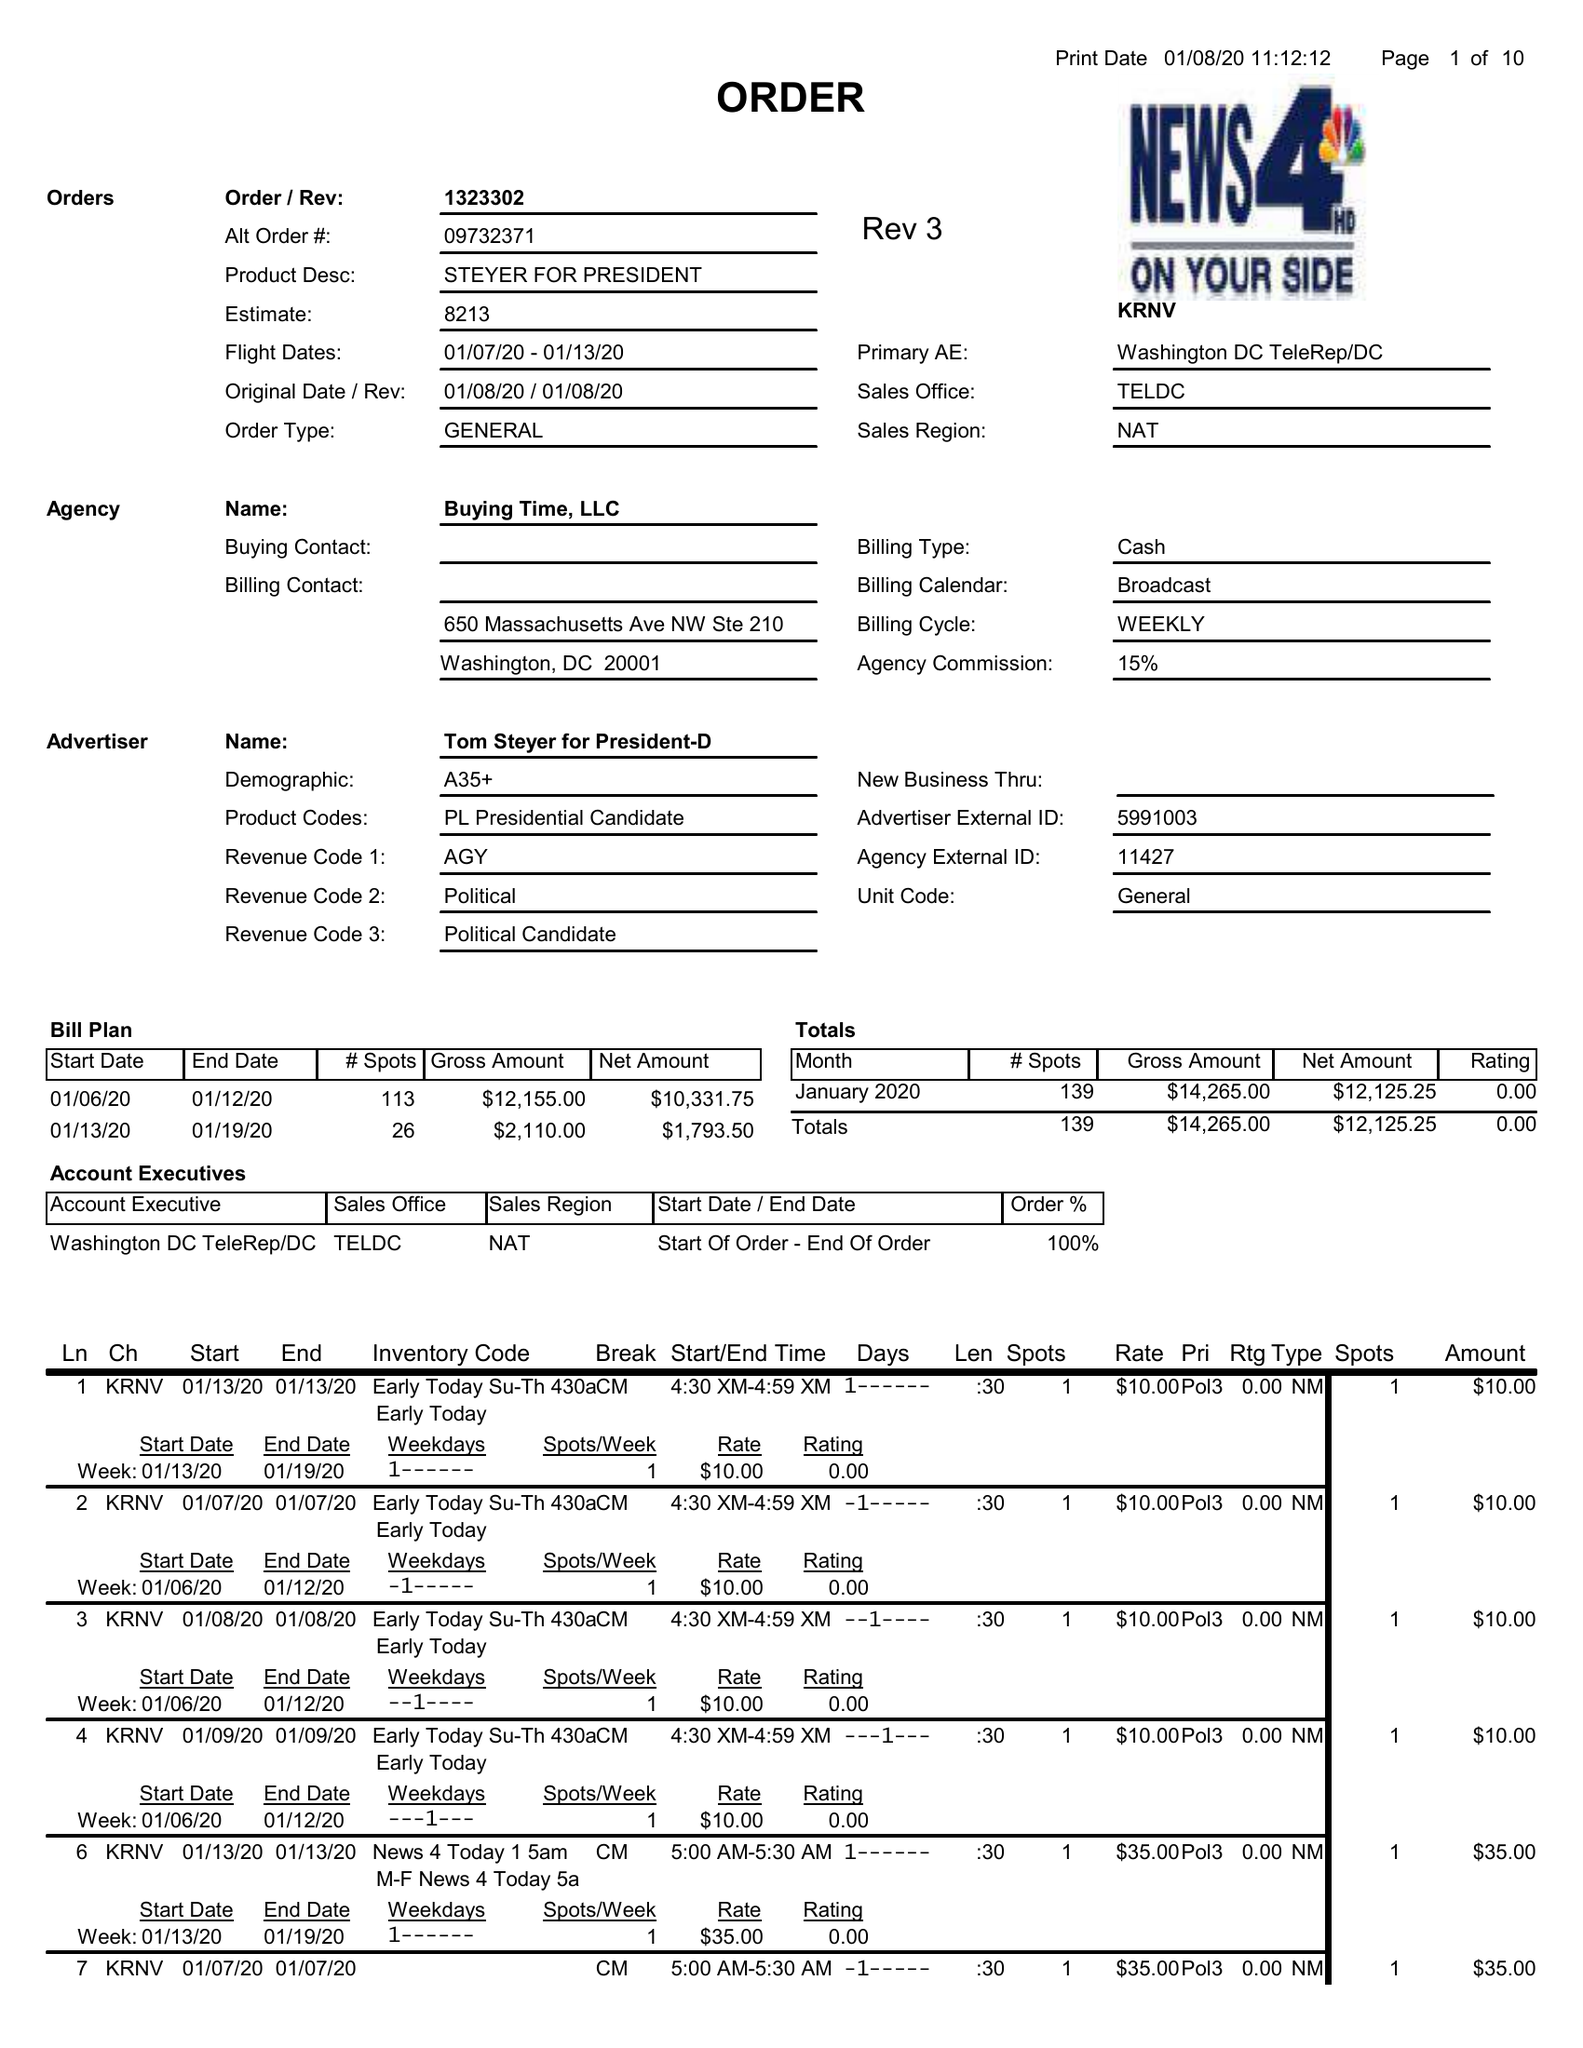What is the value for the flight_to?
Answer the question using a single word or phrase. 01/13/20 